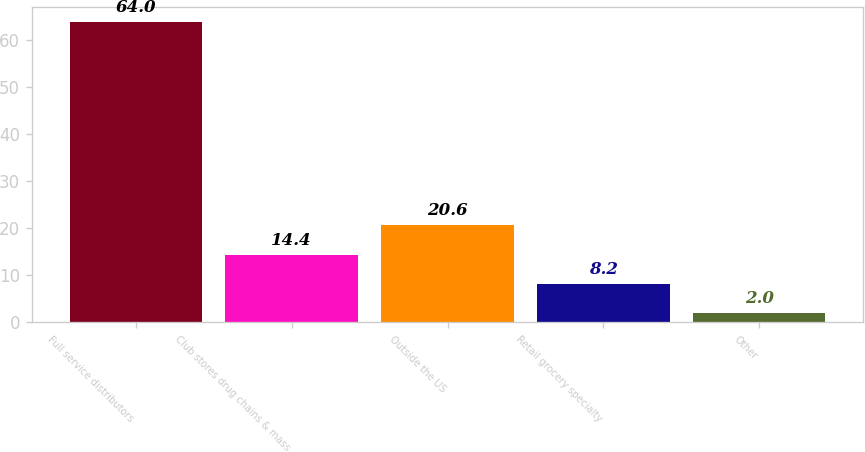Convert chart. <chart><loc_0><loc_0><loc_500><loc_500><bar_chart><fcel>Full service distributors<fcel>Club stores drug chains & mass<fcel>Outside the US<fcel>Retail grocery specialty<fcel>Other<nl><fcel>64<fcel>14.4<fcel>20.6<fcel>8.2<fcel>2<nl></chart> 